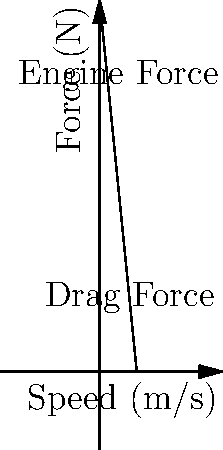As a cabdriver, you're curious about your taxi's performance. Your cab, weighing 1500 kg, accelerates from rest to 20 m/s. The engine provides a constant force of 3000 N, while air resistance increases linearly with speed, reaching 1000 N at 20 m/s. How much work does the engine do during this acceleration? Let's approach this step-by-step:

1) First, we need to find the net force acting on the car. This is the difference between the engine force and the air resistance.

2) The engine force is constant at 3000 N. The air resistance increases linearly from 0 to 1000 N.

3) The average air resistance is (0 + 1000)/2 = 500 N.

4) So, the average net force is: $F_{net} = 3000 - 500 = 2500$ N

5) Now, we can use the work-energy theorem. The work done by the net force equals the change in kinetic energy:

   $W = \Delta KE = \frac{1}{2}mv^2 - \frac{1}{2}mv_0^2$

6) Plugging in the values:
   $W = \frac{1}{2}(1500)(20^2) - \frac{1}{2}(1500)(0^2) = 300,000$ J

7) This is the work done by the net force. But we want the work done by the engine.

8) The engine does work against both the car's inertia and air resistance. So its work is:

   $W_{engine} = 3000 * 20 = 60,000$ J
Answer: 60,000 J 